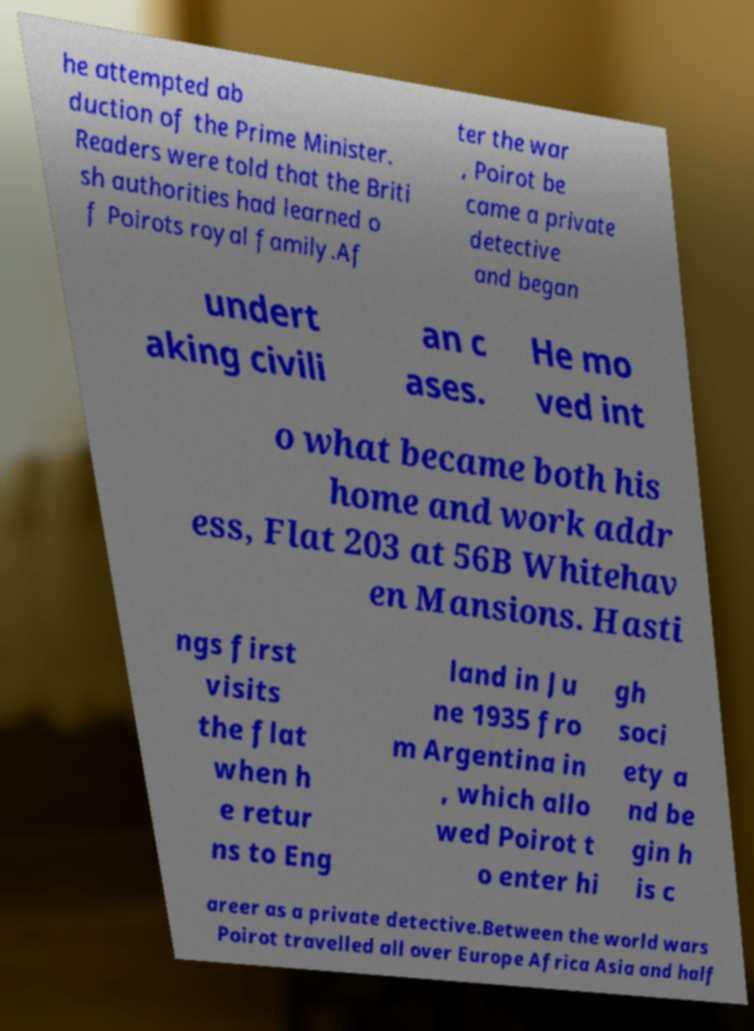There's text embedded in this image that I need extracted. Can you transcribe it verbatim? he attempted ab duction of the Prime Minister. Readers were told that the Briti sh authorities had learned o f Poirots royal family.Af ter the war , Poirot be came a private detective and began undert aking civili an c ases. He mo ved int o what became both his home and work addr ess, Flat 203 at 56B Whitehav en Mansions. Hasti ngs first visits the flat when h e retur ns to Eng land in Ju ne 1935 fro m Argentina in , which allo wed Poirot t o enter hi gh soci ety a nd be gin h is c areer as a private detective.Between the world wars Poirot travelled all over Europe Africa Asia and half 